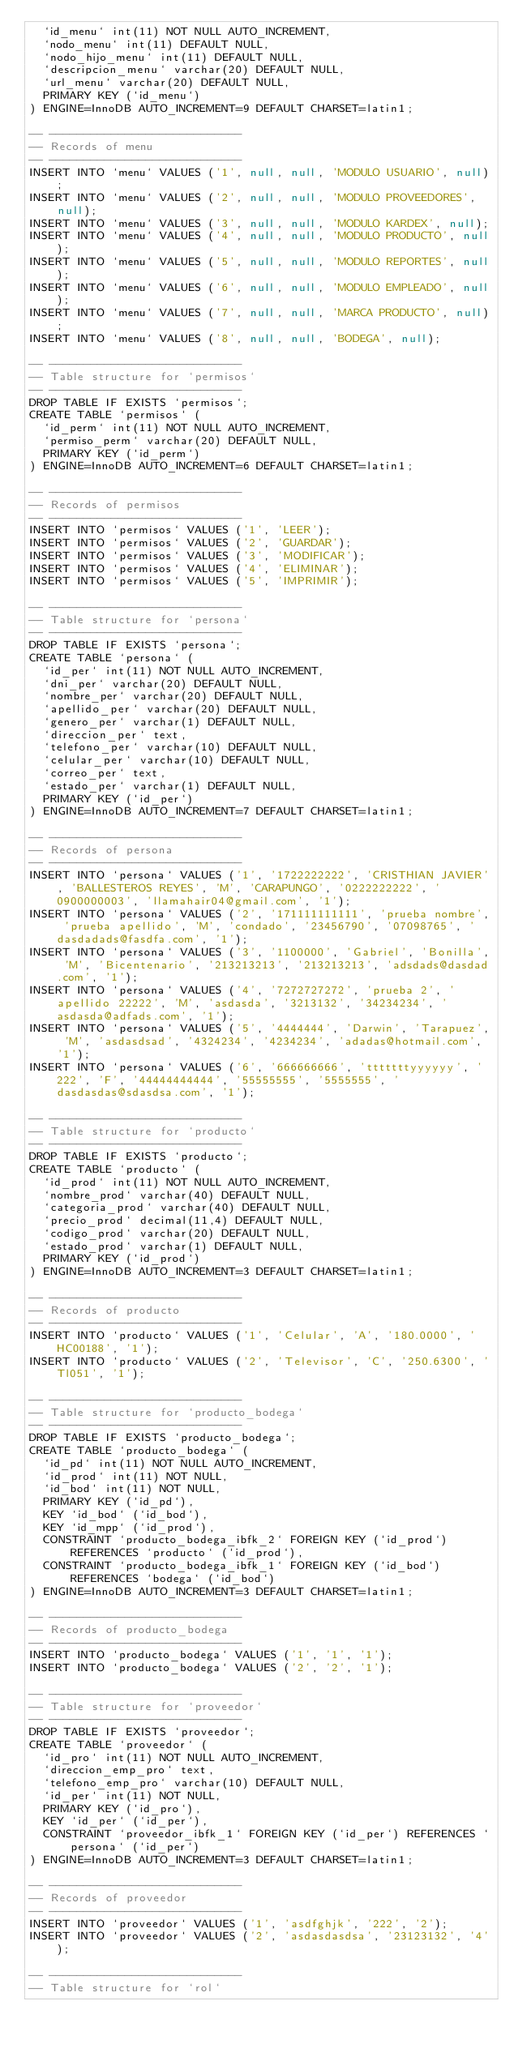Convert code to text. <code><loc_0><loc_0><loc_500><loc_500><_SQL_>  `id_menu` int(11) NOT NULL AUTO_INCREMENT,
  `nodo_menu` int(11) DEFAULT NULL,
  `nodo_hijo_menu` int(11) DEFAULT NULL,
  `descripcion_menu` varchar(20) DEFAULT NULL,
  `url_menu` varchar(20) DEFAULT NULL,
  PRIMARY KEY (`id_menu`)
) ENGINE=InnoDB AUTO_INCREMENT=9 DEFAULT CHARSET=latin1;

-- ----------------------------
-- Records of menu
-- ----------------------------
INSERT INTO `menu` VALUES ('1', null, null, 'MODULO USUARIO', null);
INSERT INTO `menu` VALUES ('2', null, null, 'MODULO PROVEEDORES', null);
INSERT INTO `menu` VALUES ('3', null, null, 'MODULO KARDEX', null);
INSERT INTO `menu` VALUES ('4', null, null, 'MODULO PRODUCTO', null);
INSERT INTO `menu` VALUES ('5', null, null, 'MODULO REPORTES', null);
INSERT INTO `menu` VALUES ('6', null, null, 'MODULO EMPLEADO', null);
INSERT INTO `menu` VALUES ('7', null, null, 'MARCA PRODUCTO', null);
INSERT INTO `menu` VALUES ('8', null, null, 'BODEGA', null);

-- ----------------------------
-- Table structure for `permisos`
-- ----------------------------
DROP TABLE IF EXISTS `permisos`;
CREATE TABLE `permisos` (
  `id_perm` int(11) NOT NULL AUTO_INCREMENT,
  `permiso_perm` varchar(20) DEFAULT NULL,
  PRIMARY KEY (`id_perm`)
) ENGINE=InnoDB AUTO_INCREMENT=6 DEFAULT CHARSET=latin1;

-- ----------------------------
-- Records of permisos
-- ----------------------------
INSERT INTO `permisos` VALUES ('1', 'LEER');
INSERT INTO `permisos` VALUES ('2', 'GUARDAR');
INSERT INTO `permisos` VALUES ('3', 'MODIFICAR');
INSERT INTO `permisos` VALUES ('4', 'ELIMINAR');
INSERT INTO `permisos` VALUES ('5', 'IMPRIMIR');

-- ----------------------------
-- Table structure for `persona`
-- ----------------------------
DROP TABLE IF EXISTS `persona`;
CREATE TABLE `persona` (
  `id_per` int(11) NOT NULL AUTO_INCREMENT,
  `dni_per` varchar(20) DEFAULT NULL,
  `nombre_per` varchar(20) DEFAULT NULL,
  `apellido_per` varchar(20) DEFAULT NULL,
  `genero_per` varchar(1) DEFAULT NULL,
  `direccion_per` text,
  `telefono_per` varchar(10) DEFAULT NULL,
  `celular_per` varchar(10) DEFAULT NULL,
  `correo_per` text,
  `estado_per` varchar(1) DEFAULT NULL,
  PRIMARY KEY (`id_per`)
) ENGINE=InnoDB AUTO_INCREMENT=7 DEFAULT CHARSET=latin1;

-- ----------------------------
-- Records of persona
-- ----------------------------
INSERT INTO `persona` VALUES ('1', '1722222222', 'CRISTHIAN JAVIER', 'BALLESTEROS REYES', 'M', 'CARAPUNGO', '0222222222', '0900000003', 'llamahair04@gmail.com', '1');
INSERT INTO `persona` VALUES ('2', '171111111111', 'prueba nombre', 'prueba apellido', 'M', 'condado', '23456790', '07098765', 'dasdadads@fasdfa.com', '1');
INSERT INTO `persona` VALUES ('3', '1100000', 'Gabriel', 'Bonilla', 'M', 'Bicentenario', '213213213', '213213213', 'adsdads@dasdad.com', '1');
INSERT INTO `persona` VALUES ('4', '7272727272', 'prueba 2', 'apellido 22222', 'M', 'asdasda', '3213132', '34234234', 'asdasda@adfads.com', '1');
INSERT INTO `persona` VALUES ('5', '4444444', 'Darwin', 'Tarapuez', 'M', 'asdasdsad', '4324234', '4234234', 'adadas@hotmail.com', '1');
INSERT INTO `persona` VALUES ('6', '666666666', 'tttttttyyyyyy', '222', 'F', '44444444444', '55555555', '5555555', 'dasdasdas@sdasdsa.com', '1');

-- ----------------------------
-- Table structure for `producto`
-- ----------------------------
DROP TABLE IF EXISTS `producto`;
CREATE TABLE `producto` (
  `id_prod` int(11) NOT NULL AUTO_INCREMENT,
  `nombre_prod` varchar(40) DEFAULT NULL,
  `categoria_prod` varchar(40) DEFAULT NULL,
  `precio_prod` decimal(11,4) DEFAULT NULL,
  `codigo_prod` varchar(20) DEFAULT NULL,
  `estado_prod` varchar(1) DEFAULT NULL,
  PRIMARY KEY (`id_prod`)
) ENGINE=InnoDB AUTO_INCREMENT=3 DEFAULT CHARSET=latin1;

-- ----------------------------
-- Records of producto
-- ----------------------------
INSERT INTO `producto` VALUES ('1', 'Celular', 'A', '180.0000', 'HC00188', '1');
INSERT INTO `producto` VALUES ('2', 'Televisor', 'C', '250.6300', 'Tl051', '1');

-- ----------------------------
-- Table structure for `producto_bodega`
-- ----------------------------
DROP TABLE IF EXISTS `producto_bodega`;
CREATE TABLE `producto_bodega` (
  `id_pd` int(11) NOT NULL AUTO_INCREMENT,
  `id_prod` int(11) NOT NULL,
  `id_bod` int(11) NOT NULL,
  PRIMARY KEY (`id_pd`),
  KEY `id_bod` (`id_bod`),
  KEY `id_mpp` (`id_prod`),
  CONSTRAINT `producto_bodega_ibfk_2` FOREIGN KEY (`id_prod`) REFERENCES `producto` (`id_prod`),
  CONSTRAINT `producto_bodega_ibfk_1` FOREIGN KEY (`id_bod`) REFERENCES `bodega` (`id_bod`)
) ENGINE=InnoDB AUTO_INCREMENT=3 DEFAULT CHARSET=latin1;

-- ----------------------------
-- Records of producto_bodega
-- ----------------------------
INSERT INTO `producto_bodega` VALUES ('1', '1', '1');
INSERT INTO `producto_bodega` VALUES ('2', '2', '1');

-- ----------------------------
-- Table structure for `proveedor`
-- ----------------------------
DROP TABLE IF EXISTS `proveedor`;
CREATE TABLE `proveedor` (
  `id_pro` int(11) NOT NULL AUTO_INCREMENT,
  `direccion_emp_pro` text,
  `telefono_emp_pro` varchar(10) DEFAULT NULL,
  `id_per` int(11) NOT NULL,
  PRIMARY KEY (`id_pro`),
  KEY `id_per` (`id_per`),
  CONSTRAINT `proveedor_ibfk_1` FOREIGN KEY (`id_per`) REFERENCES `persona` (`id_per`)
) ENGINE=InnoDB AUTO_INCREMENT=3 DEFAULT CHARSET=latin1;

-- ----------------------------
-- Records of proveedor
-- ----------------------------
INSERT INTO `proveedor` VALUES ('1', 'asdfghjk', '222', '2');
INSERT INTO `proveedor` VALUES ('2', 'asdasdasdsa', '23123132', '4');

-- ----------------------------
-- Table structure for `rol`</code> 